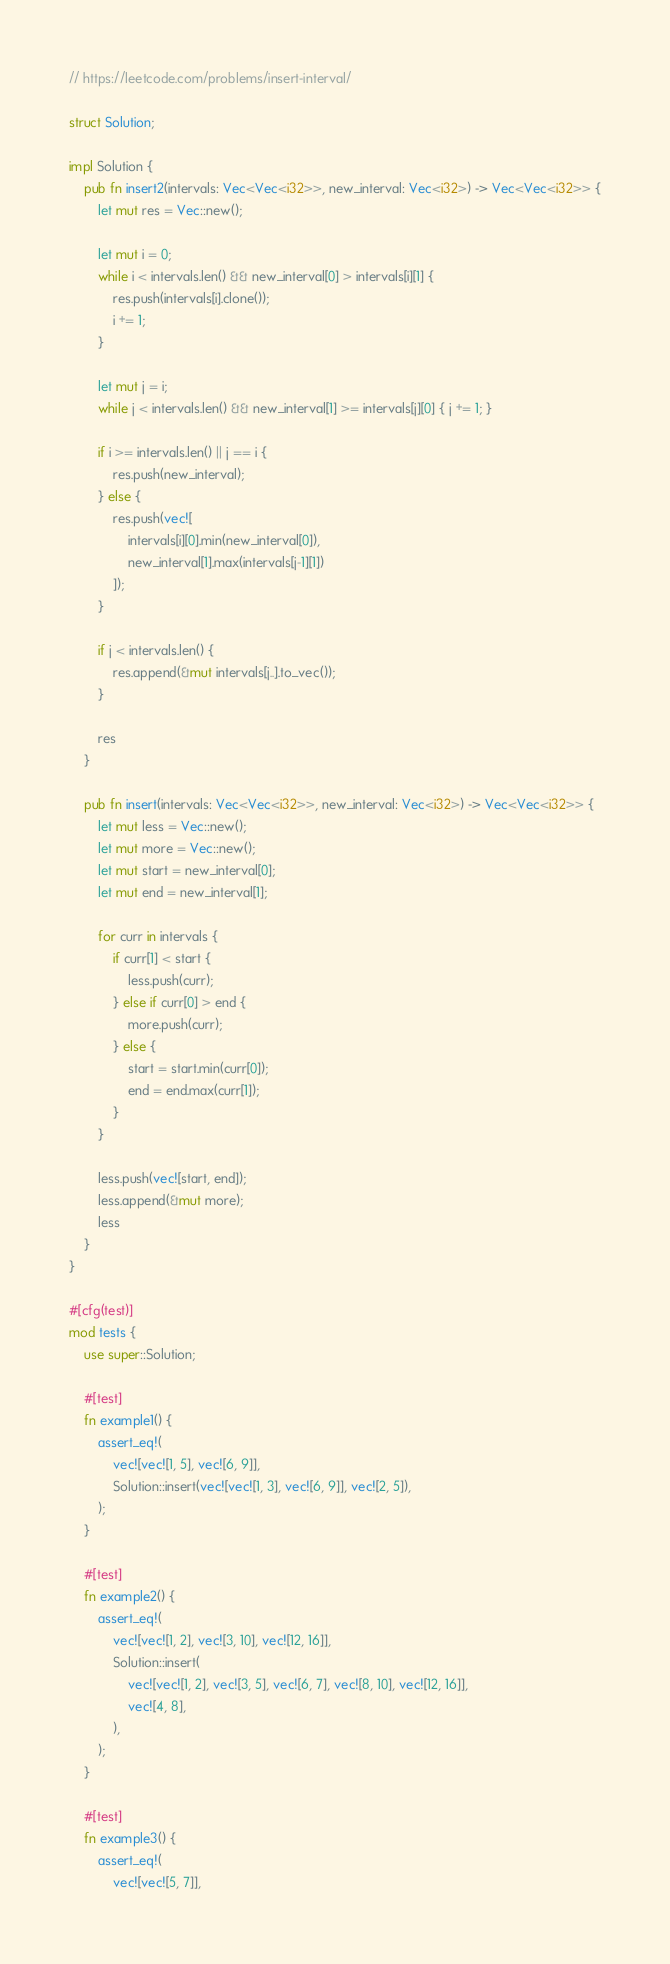<code> <loc_0><loc_0><loc_500><loc_500><_Rust_>// https://leetcode.com/problems/insert-interval/

struct Solution;

impl Solution {
    pub fn insert2(intervals: Vec<Vec<i32>>, new_interval: Vec<i32>) -> Vec<Vec<i32>> {
        let mut res = Vec::new();

        let mut i = 0;
        while i < intervals.len() && new_interval[0] > intervals[i][1] {
            res.push(intervals[i].clone());
            i += 1;
        }

        let mut j = i;
        while j < intervals.len() && new_interval[1] >= intervals[j][0] { j += 1; }

        if i >= intervals.len() || j == i {
            res.push(new_interval);
        } else {
            res.push(vec![
                intervals[i][0].min(new_interval[0]),
                new_interval[1].max(intervals[j-1][1])
            ]);
        }

        if j < intervals.len() {
            res.append(&mut intervals[j..].to_vec());
        }

        res
    }

    pub fn insert(intervals: Vec<Vec<i32>>, new_interval: Vec<i32>) -> Vec<Vec<i32>> {
        let mut less = Vec::new();
        let mut more = Vec::new();
        let mut start = new_interval[0];
        let mut end = new_interval[1];

        for curr in intervals {
            if curr[1] < start {
                less.push(curr);
            } else if curr[0] > end {
                more.push(curr);
            } else {
                start = start.min(curr[0]);
                end = end.max(curr[1]);
            }
        }

        less.push(vec![start, end]);
        less.append(&mut more);
        less
    }
}

#[cfg(test)]
mod tests {
    use super::Solution;

    #[test]
    fn example1() {
        assert_eq!(
            vec![vec![1, 5], vec![6, 9]],
            Solution::insert(vec![vec![1, 3], vec![6, 9]], vec![2, 5]),
        );
    }

    #[test]
    fn example2() {
        assert_eq!(
            vec![vec![1, 2], vec![3, 10], vec![12, 16]],
            Solution::insert(
                vec![vec![1, 2], vec![3, 5], vec![6, 7], vec![8, 10], vec![12, 16]],
                vec![4, 8],
            ),
        );
    }

    #[test]
    fn example3() {
        assert_eq!(
            vec![vec![5, 7]],</code> 